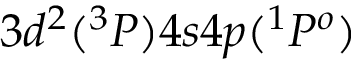Convert formula to latex. <formula><loc_0><loc_0><loc_500><loc_500>3 d ^ { 2 } ( ^ { 3 } P ) 4 s 4 p ( ^ { 1 } P ^ { o } )</formula> 